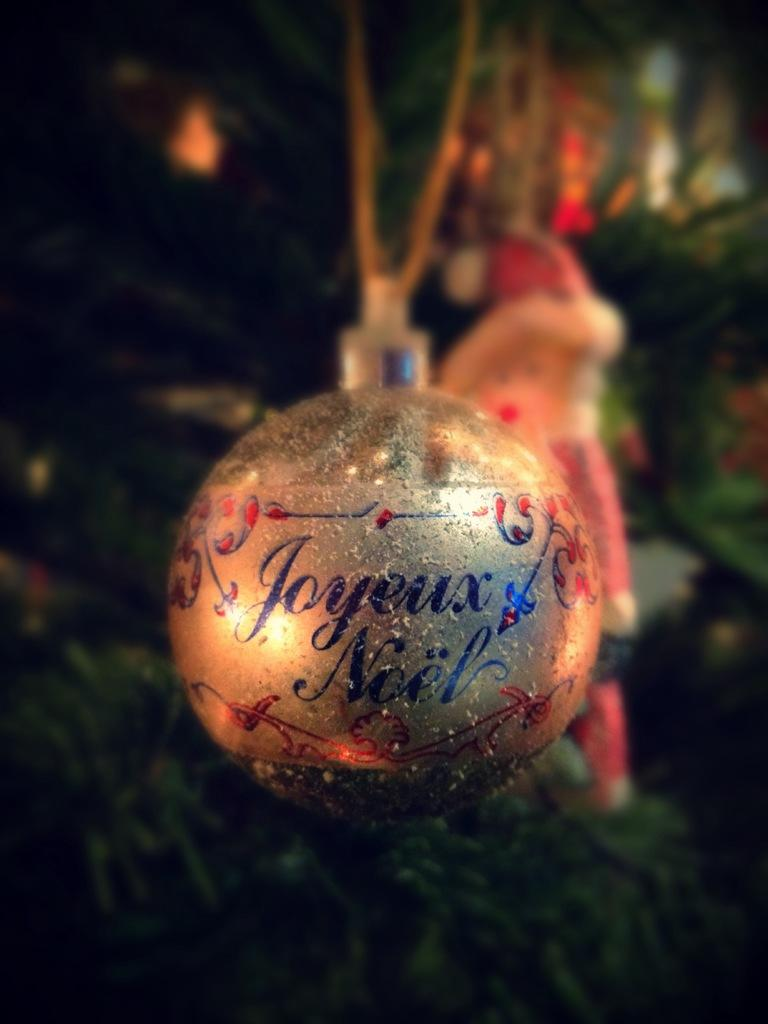What is: What type of object is featured in the image? There is a Christmas ornament in the image. What is the color of the ornament? The ornament is gold in color. Are there any words or letters on the ornament? Yes, there is text on the ornament. How would you describe the background of the image? The background of the image is blurred and dark. How much dirt is visible on the root of the Christmas ornament in the image? There is no dirt or root present in the image, as it features a gold Christmas ornament with text and a blurred, dark background. 